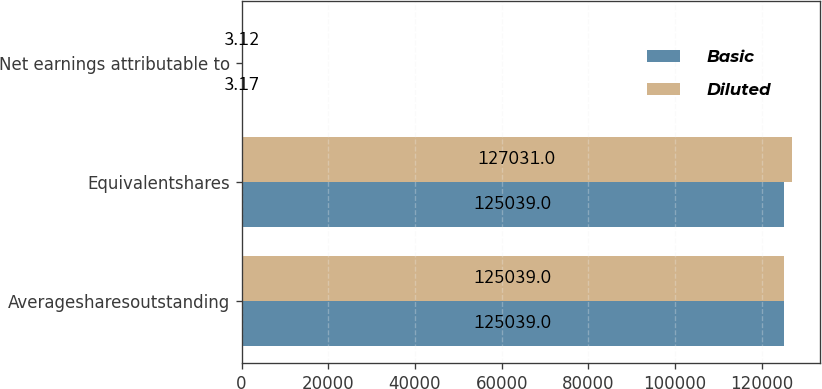Convert chart. <chart><loc_0><loc_0><loc_500><loc_500><stacked_bar_chart><ecel><fcel>Averagesharesoutstanding<fcel>Equivalentshares<fcel>Net earnings attributable to<nl><fcel>Basic<fcel>125039<fcel>125039<fcel>3.17<nl><fcel>Diluted<fcel>125039<fcel>127031<fcel>3.12<nl></chart> 